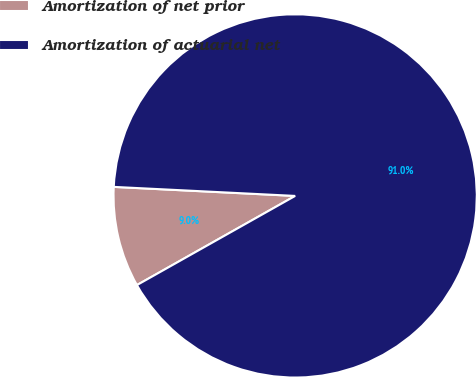Convert chart. <chart><loc_0><loc_0><loc_500><loc_500><pie_chart><fcel>Amortization of net prior<fcel>Amortization of actuarial net<nl><fcel>8.96%<fcel>91.04%<nl></chart> 